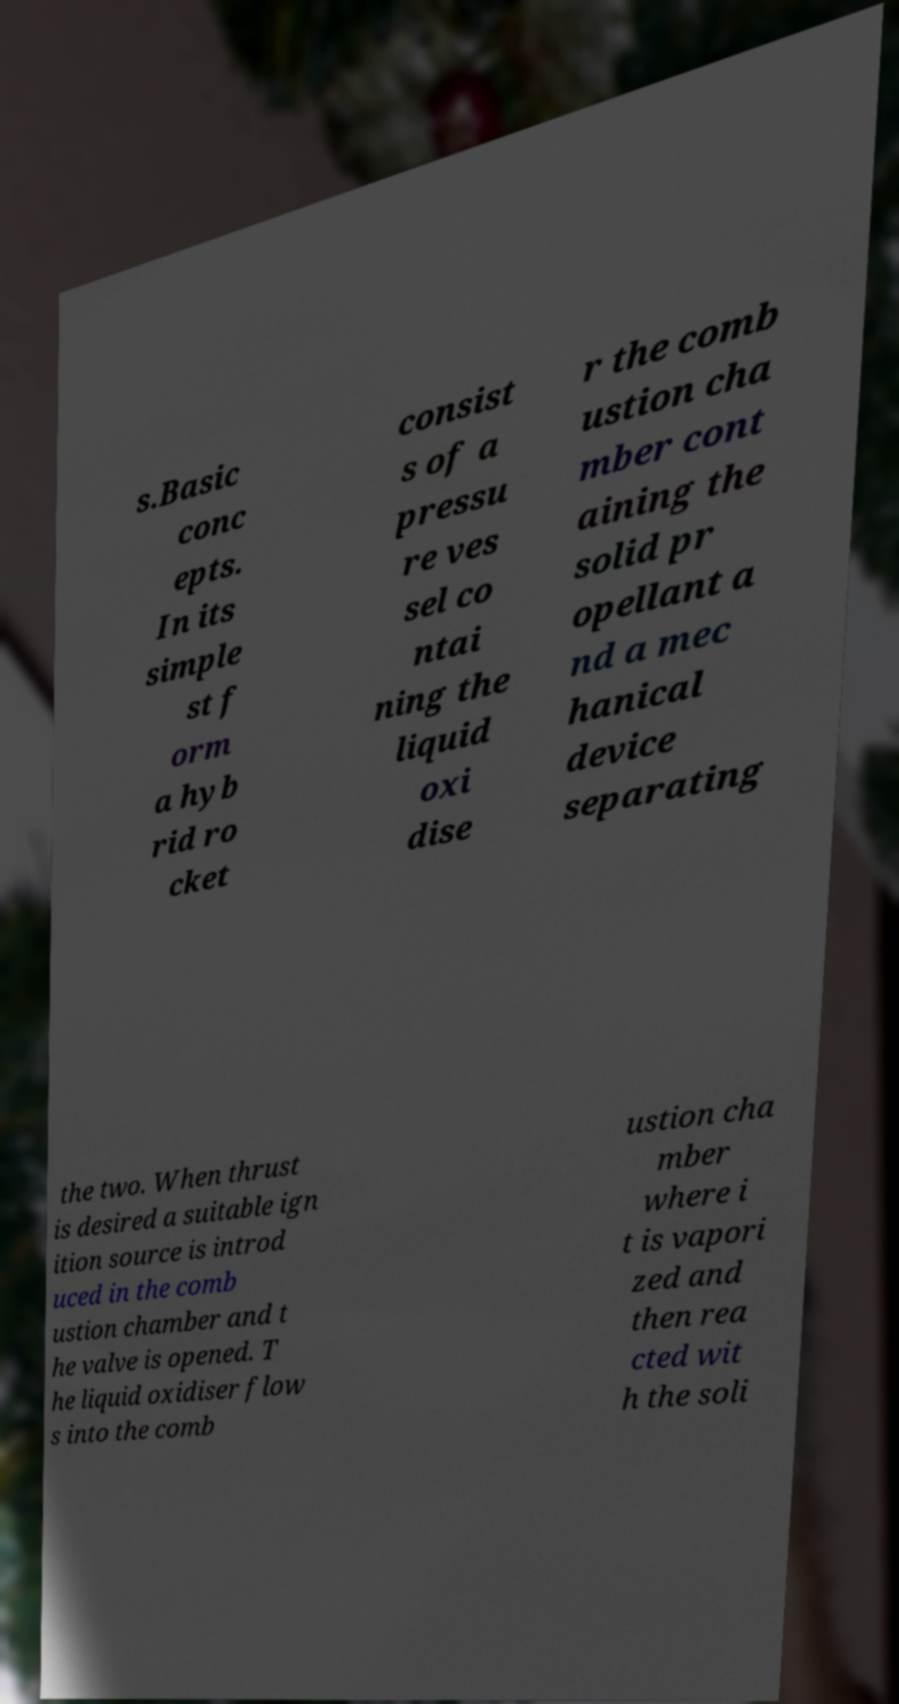Please identify and transcribe the text found in this image. s.Basic conc epts. In its simple st f orm a hyb rid ro cket consist s of a pressu re ves sel co ntai ning the liquid oxi dise r the comb ustion cha mber cont aining the solid pr opellant a nd a mec hanical device separating the two. When thrust is desired a suitable ign ition source is introd uced in the comb ustion chamber and t he valve is opened. T he liquid oxidiser flow s into the comb ustion cha mber where i t is vapori zed and then rea cted wit h the soli 